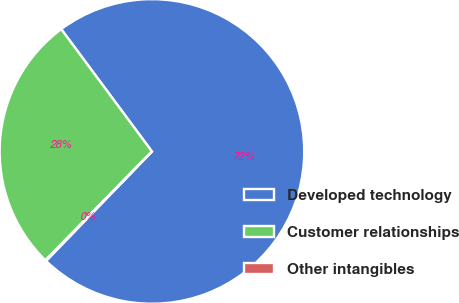Convert chart to OTSL. <chart><loc_0><loc_0><loc_500><loc_500><pie_chart><fcel>Developed technology<fcel>Customer relationships<fcel>Other intangibles<nl><fcel>72.38%<fcel>27.51%<fcel>0.1%<nl></chart> 